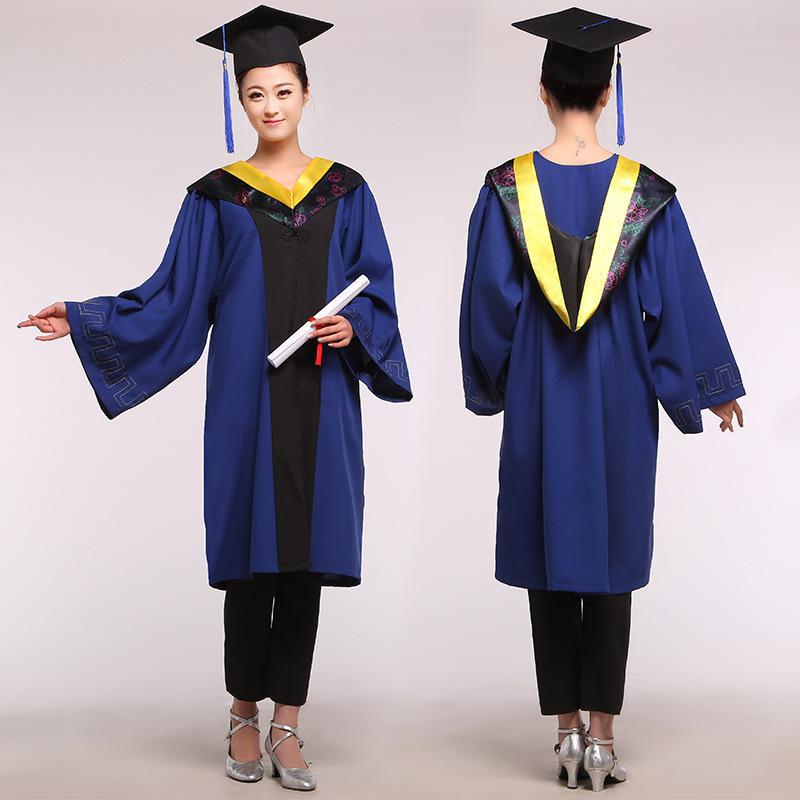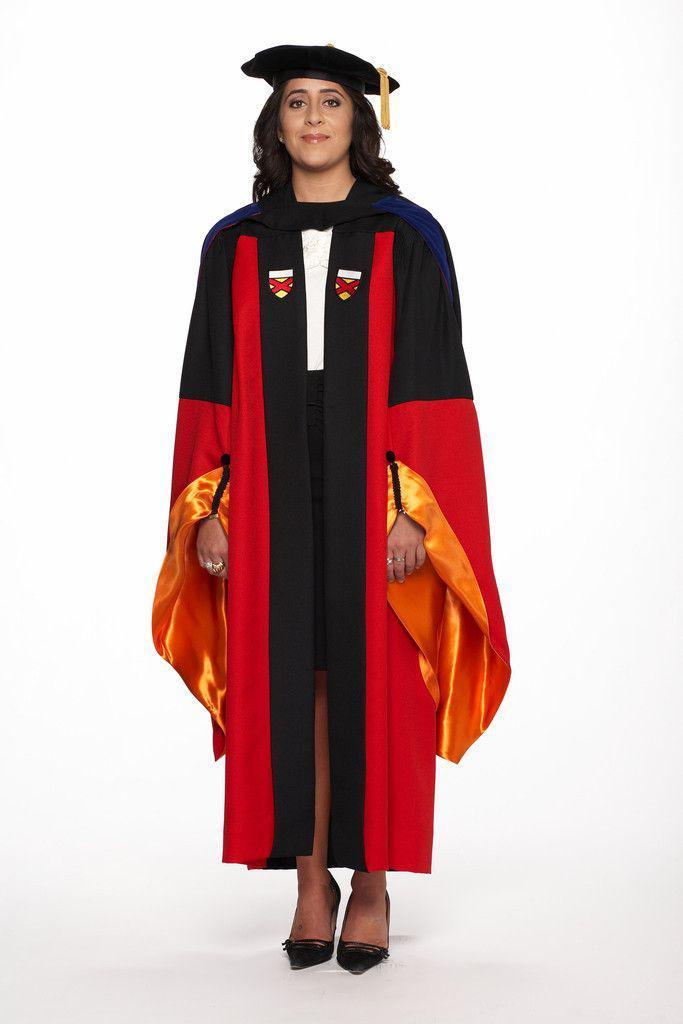The first image is the image on the left, the second image is the image on the right. For the images shown, is this caption "One person is wearing red." true? Answer yes or no. Yes. 